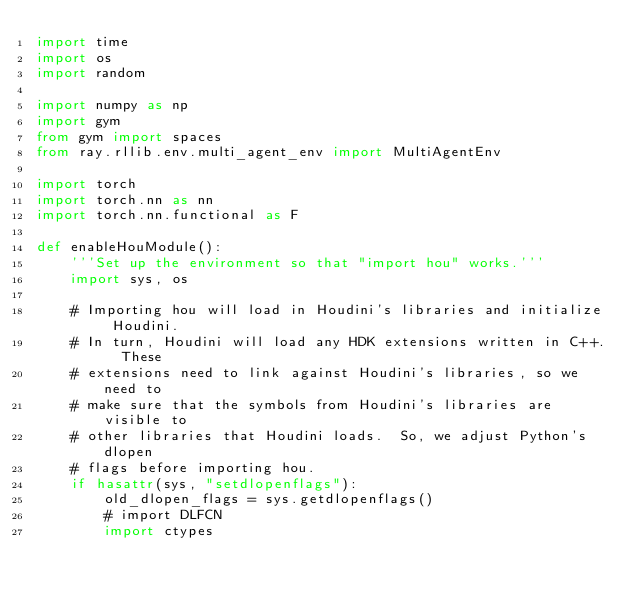Convert code to text. <code><loc_0><loc_0><loc_500><loc_500><_Python_>import time
import os
import random

import numpy as np
import gym
from gym import spaces
from ray.rllib.env.multi_agent_env import MultiAgentEnv

import torch
import torch.nn as nn
import torch.nn.functional as F

def enableHouModule():
    '''Set up the environment so that "import hou" works.'''
    import sys, os

    # Importing hou will load in Houdini's libraries and initialize Houdini.
    # In turn, Houdini will load any HDK extensions written in C++.  These
    # extensions need to link against Houdini's libraries, so we need to
    # make sure that the symbols from Houdini's libraries are visible to
    # other libraries that Houdini loads.  So, we adjust Python's dlopen
    # flags before importing hou.
    if hasattr(sys, "setdlopenflags"):
        old_dlopen_flags = sys.getdlopenflags()
        # import DLFCN
        import ctypes</code> 